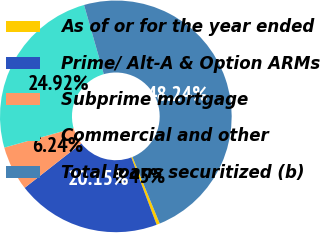Convert chart. <chart><loc_0><loc_0><loc_500><loc_500><pie_chart><fcel>As of or for the year ended<fcel>Prime/ Alt-A & Option ARMs<fcel>Subprime mortgage<fcel>Commercial and other<fcel>Total loans securitized (b)<nl><fcel>0.45%<fcel>20.15%<fcel>6.24%<fcel>24.92%<fcel>48.24%<nl></chart> 